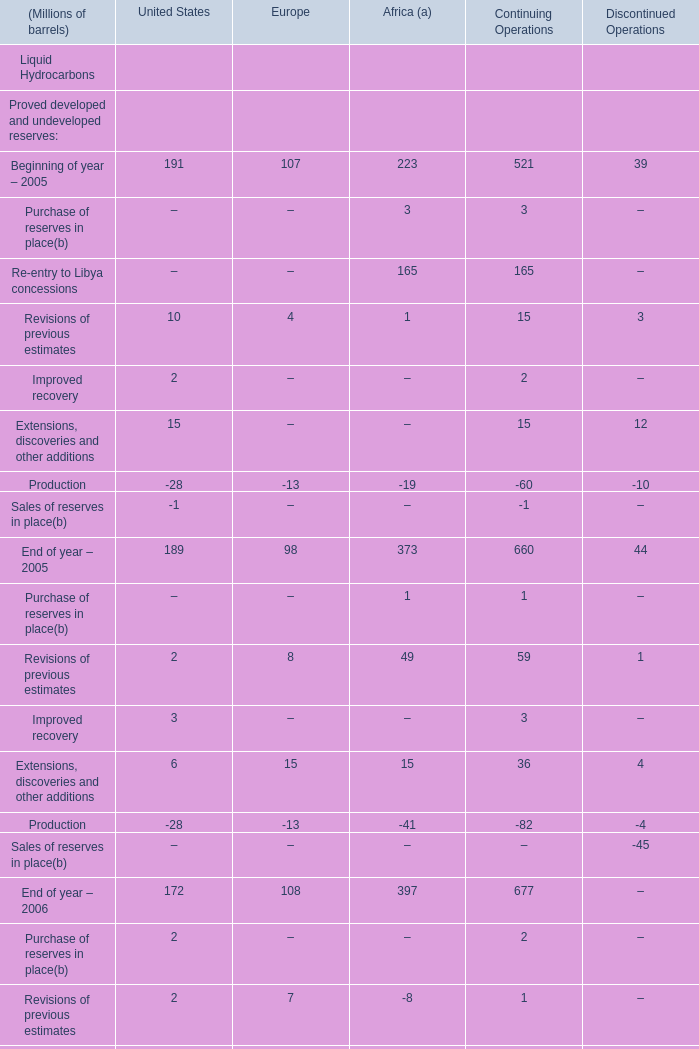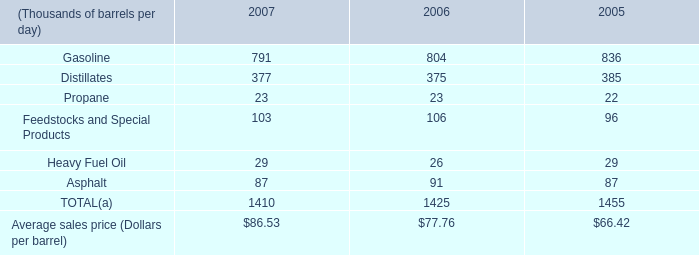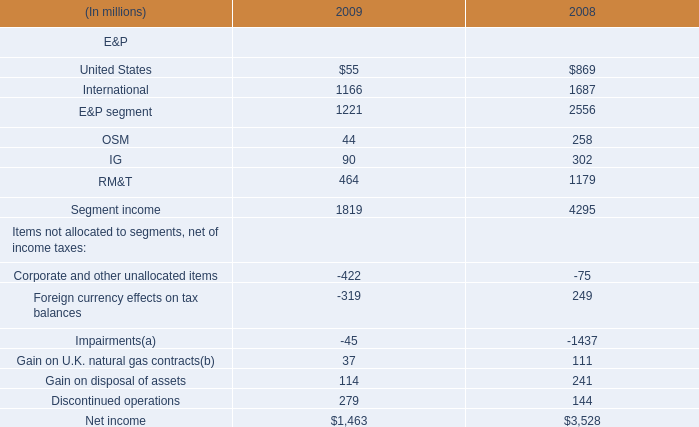What was the average of the Extensions, discoveries and other additions for United States in the years where Purchase of reserves in place is positive for United States? (in Million) 
Computations: ((6 + 5) / 2)
Answer: 5.5. 